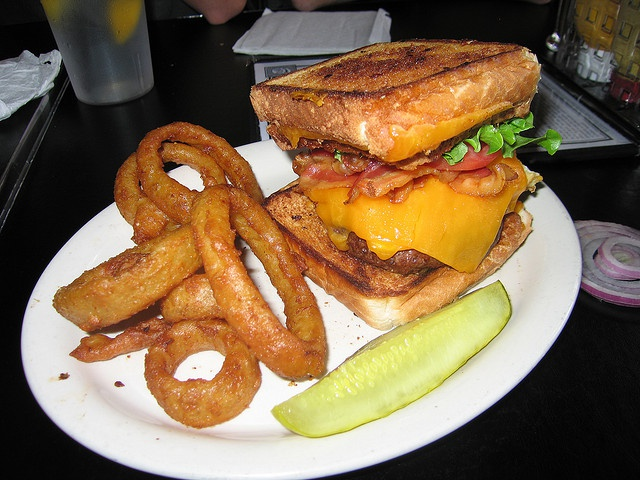Describe the objects in this image and their specific colors. I can see dining table in black, lightgray, red, and orange tones, sandwich in black, brown, orange, and maroon tones, cup in black, gray, and olive tones, and knife in black and gray tones in this image. 